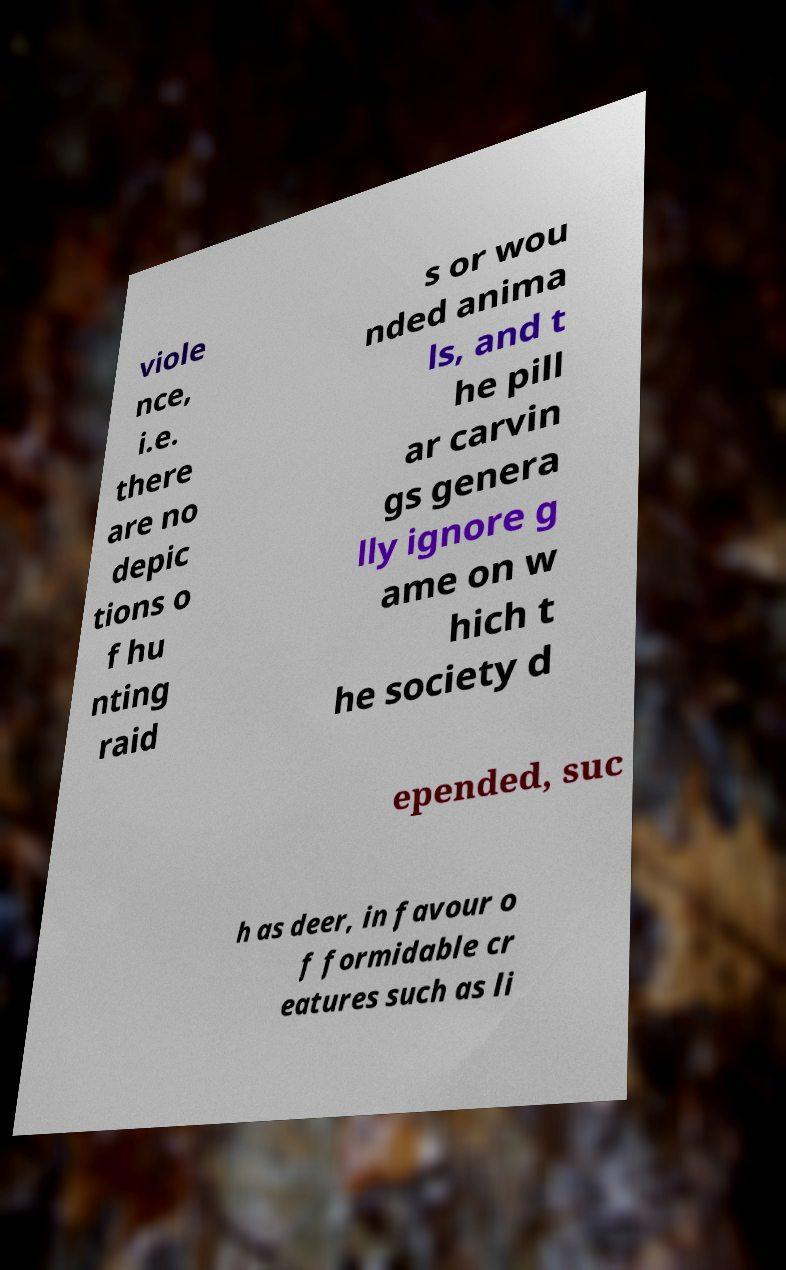What messages or text are displayed in this image? I need them in a readable, typed format. viole nce, i.e. there are no depic tions o f hu nting raid s or wou nded anima ls, and t he pill ar carvin gs genera lly ignore g ame on w hich t he society d epended, suc h as deer, in favour o f formidable cr eatures such as li 